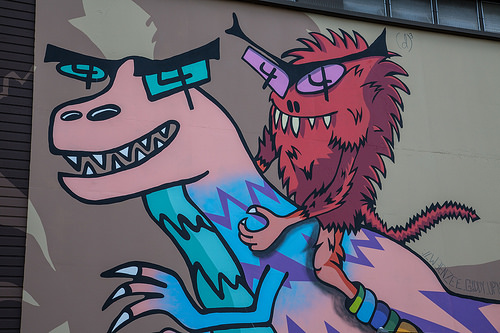<image>
Is the fuzzy monster on the pink dinosaur? Yes. Looking at the image, I can see the fuzzy monster is positioned on top of the pink dinosaur, with the pink dinosaur providing support. 